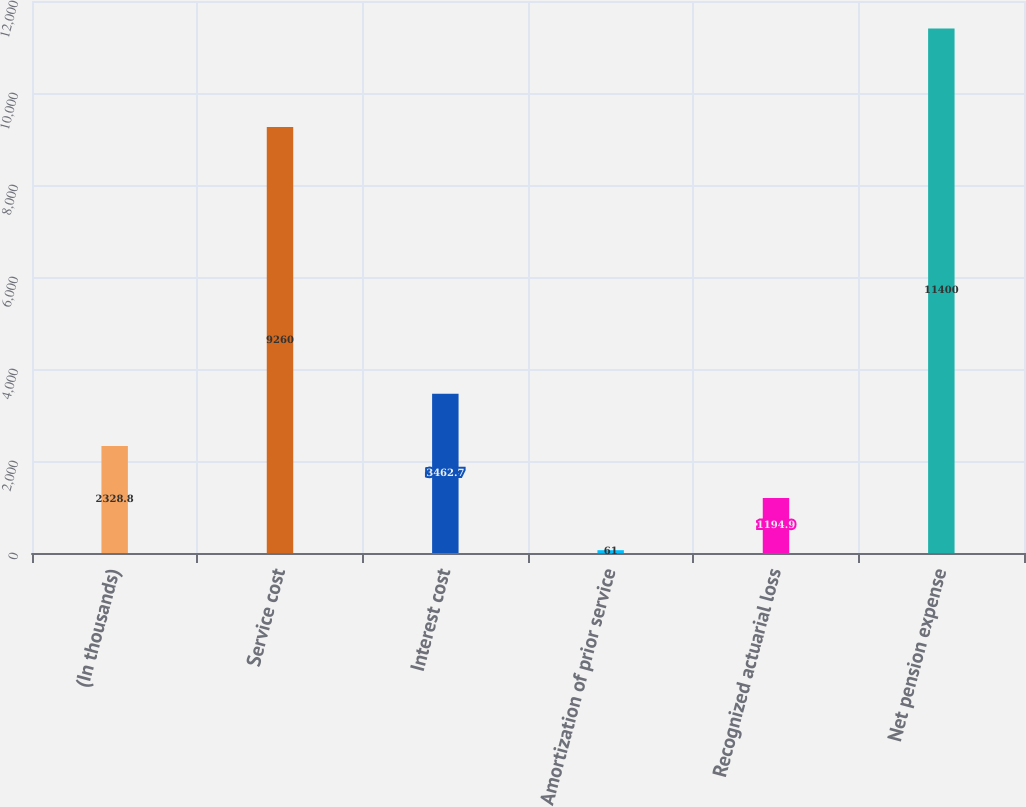Convert chart. <chart><loc_0><loc_0><loc_500><loc_500><bar_chart><fcel>(In thousands)<fcel>Service cost<fcel>Interest cost<fcel>Amortization of prior service<fcel>Recognized actuarial loss<fcel>Net pension expense<nl><fcel>2328.8<fcel>9260<fcel>3462.7<fcel>61<fcel>1194.9<fcel>11400<nl></chart> 